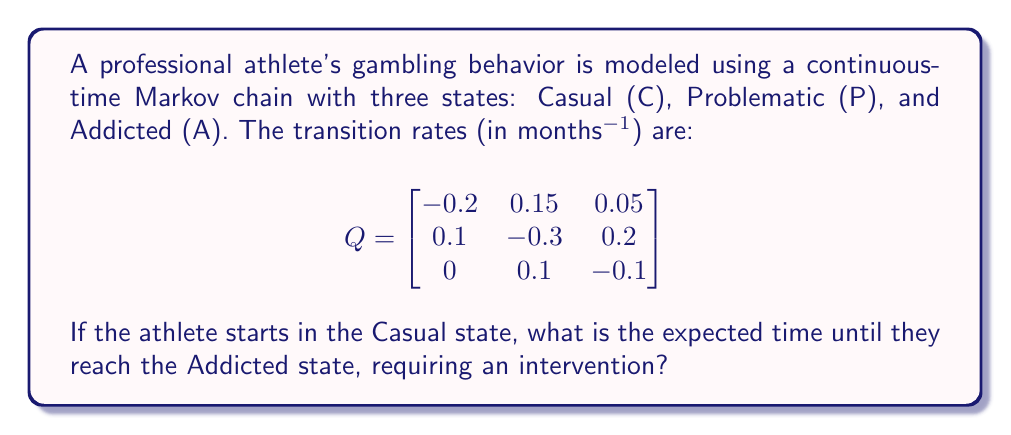Show me your answer to this math problem. To solve this problem, we'll use the concept of mean first passage times in continuous-time Markov chains.

Step 1: Define the mean first passage time vector $\mathbf{m}$ from states C and P to state A.
Let $m_C$ and $m_P$ be the mean times to reach A from C and P, respectively.

Step 2: Set up the system of linear equations based on the transition rates:
$$\begin{aligned}
m_C &= \frac{1}{0.2} + \frac{0.15}{0.2}m_P + \frac{0.05}{0.2} \cdot 0 \\
m_P &= \frac{1}{0.3} + \frac{0.1}{0.3}m_C + \frac{0.2}{0.3} \cdot 0
\end{aligned}$$

Step 3: Simplify the equations:
$$\begin{aligned}
m_C &= 5 + 0.75m_P \\
m_P &= \frac{10}{3} + \frac{1}{3}m_C
\end{aligned}$$

Step 4: Substitute the second equation into the first:
$$\begin{aligned}
m_C &= 5 + 0.75(\frac{10}{3} + \frac{1}{3}m_C) \\
m_C &= 5 + 2.5 + 0.25m_C \\
0.75m_C &= 7.5 \\
m_C &= 10
\end{aligned}$$

Step 5: The expected time to reach the Addicted state from the Casual state is 10 months.
Answer: 10 months 